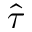<formula> <loc_0><loc_0><loc_500><loc_500>\hat { \tau }</formula> 